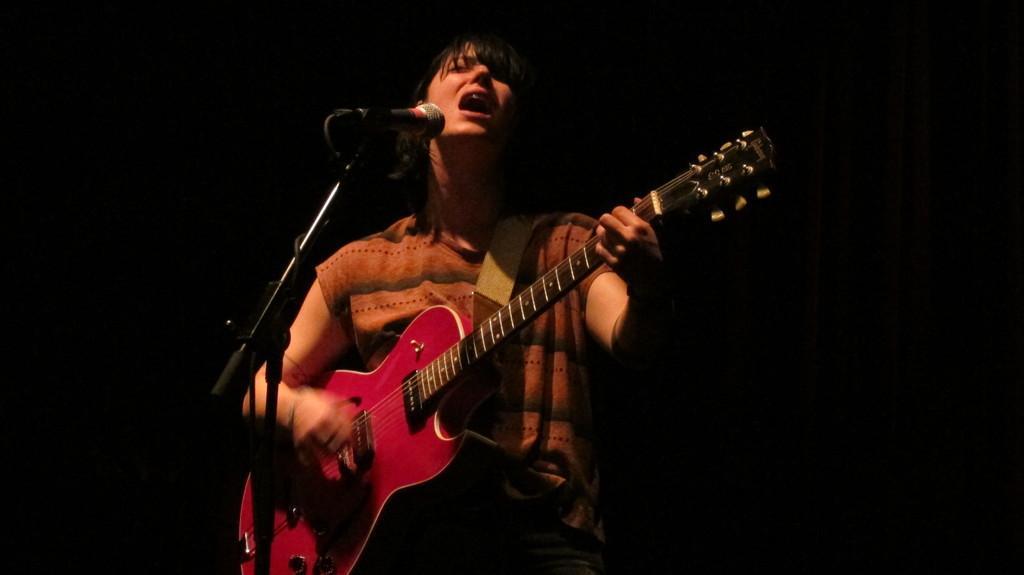In one or two sentences, can you explain what this image depicts? In this image i can see a woman is playing a guitar in front of a microphone. 